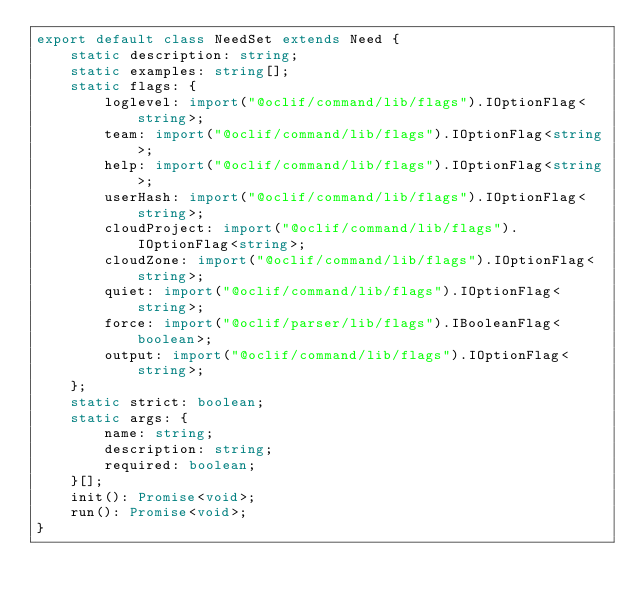<code> <loc_0><loc_0><loc_500><loc_500><_TypeScript_>export default class NeedSet extends Need {
    static description: string;
    static examples: string[];
    static flags: {
        loglevel: import("@oclif/command/lib/flags").IOptionFlag<string>;
        team: import("@oclif/command/lib/flags").IOptionFlag<string>;
        help: import("@oclif/command/lib/flags").IOptionFlag<string>;
        userHash: import("@oclif/command/lib/flags").IOptionFlag<string>;
        cloudProject: import("@oclif/command/lib/flags").IOptionFlag<string>;
        cloudZone: import("@oclif/command/lib/flags").IOptionFlag<string>;
        quiet: import("@oclif/command/lib/flags").IOptionFlag<string>;
        force: import("@oclif/parser/lib/flags").IBooleanFlag<boolean>;
        output: import("@oclif/command/lib/flags").IOptionFlag<string>;
    };
    static strict: boolean;
    static args: {
        name: string;
        description: string;
        required: boolean;
    }[];
    init(): Promise<void>;
    run(): Promise<void>;
}
</code> 